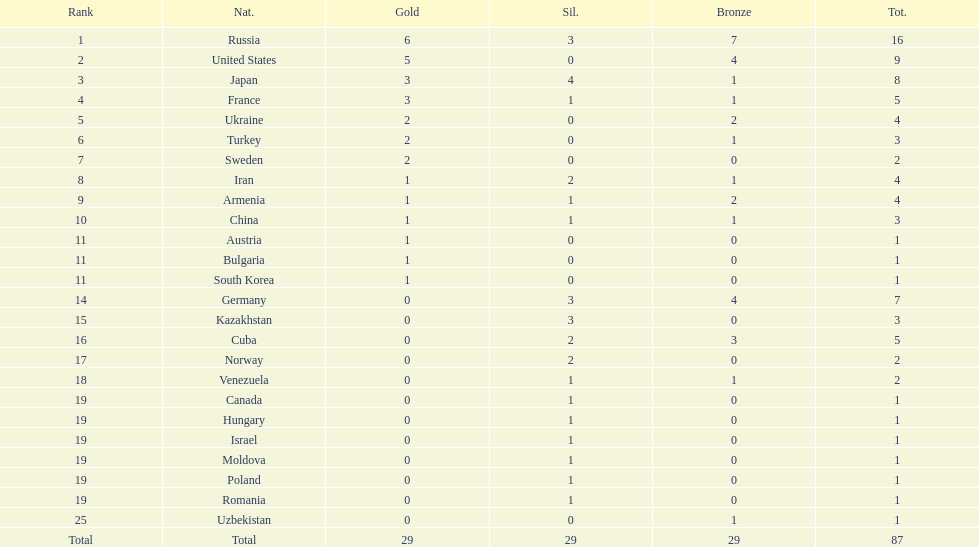Which nation was not in the top 10 iran or germany? Germany. 